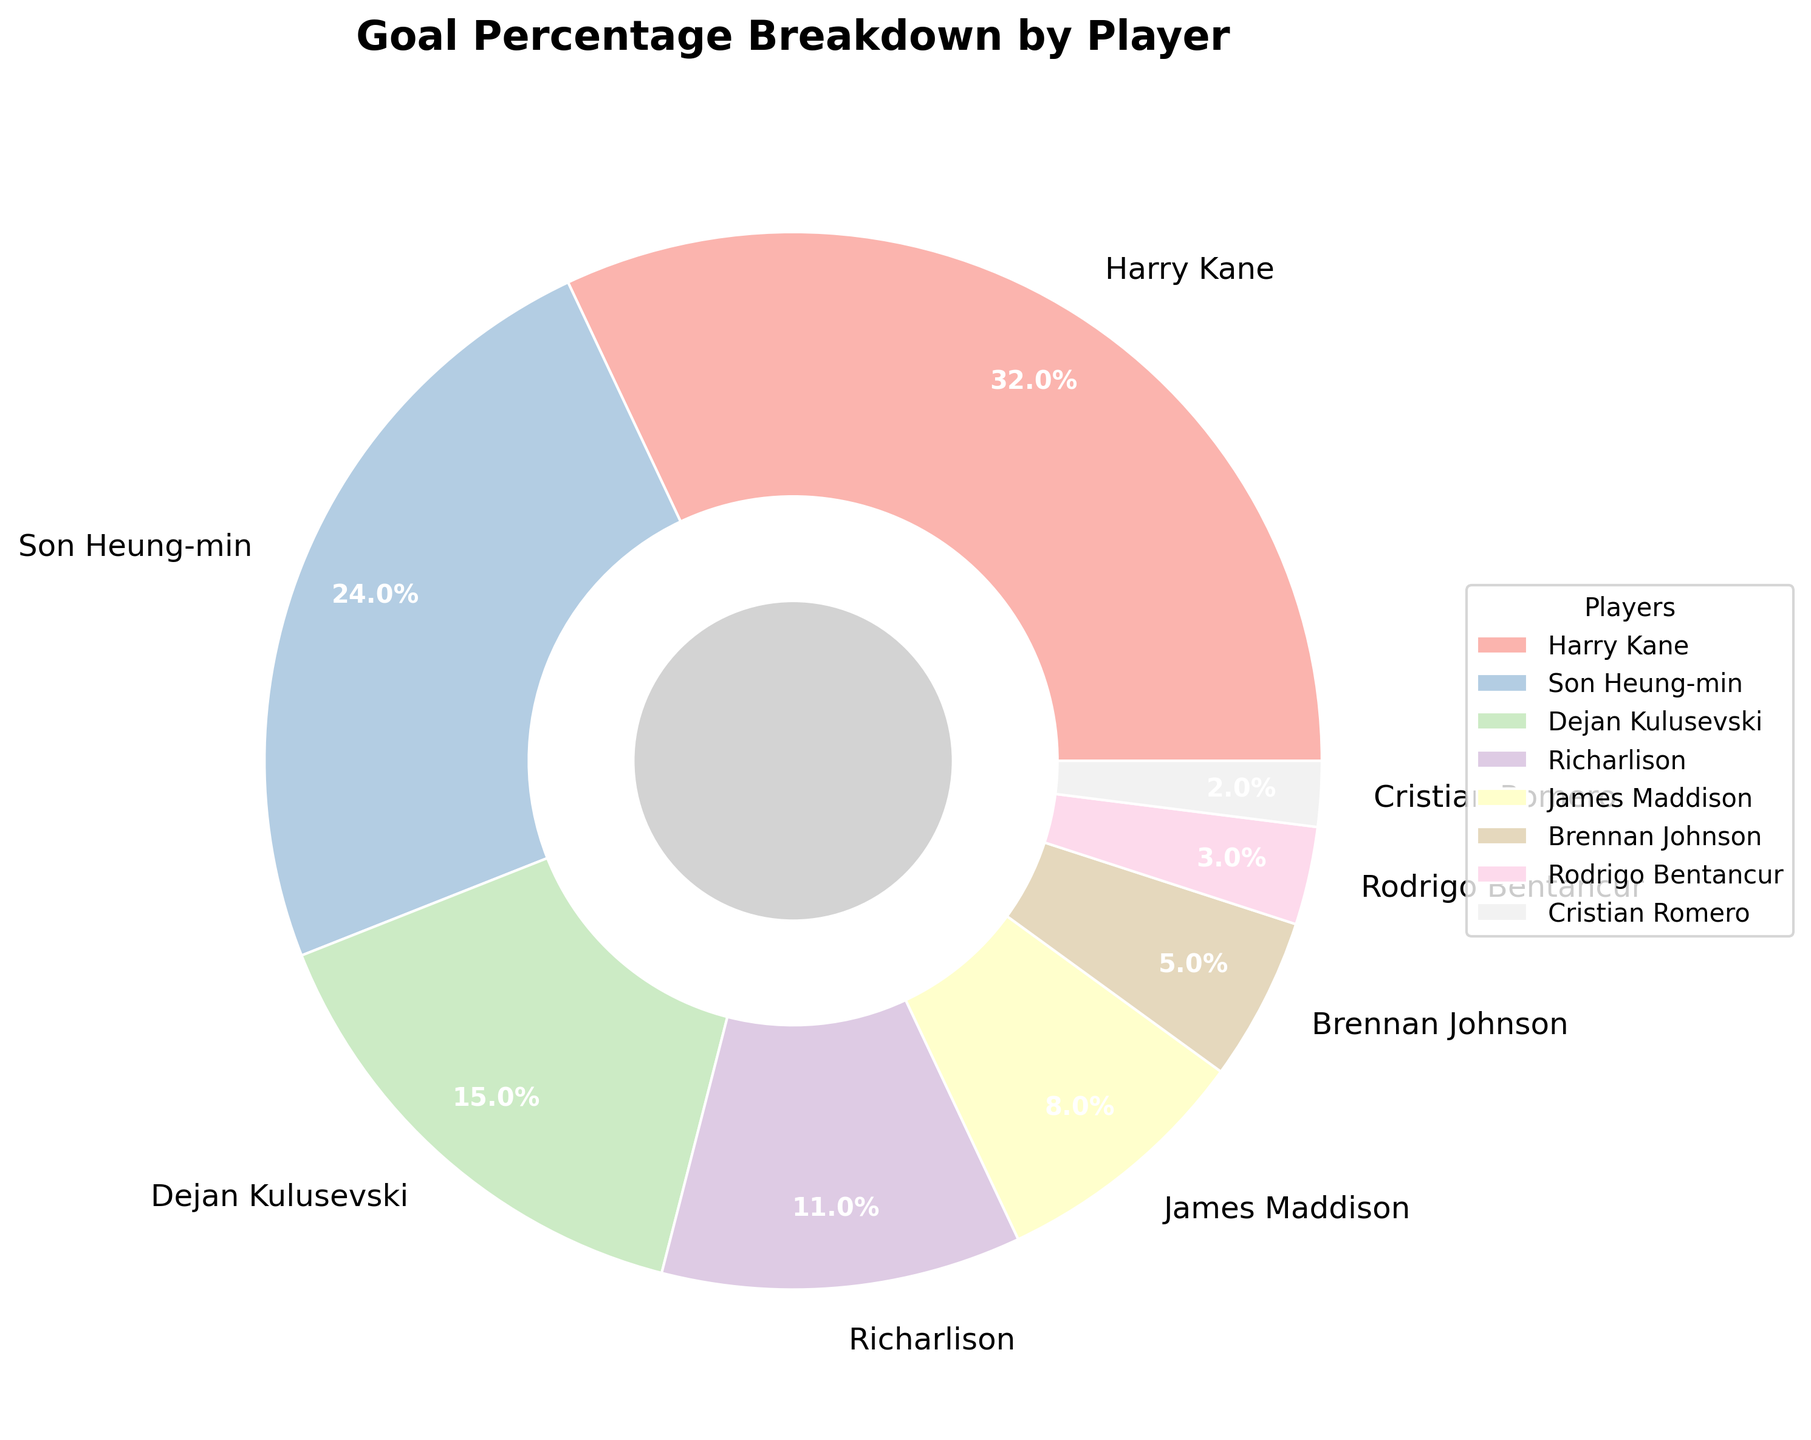What percentage of the team's goals were scored by Harry Kane and Son Heung-min combined? Add the percentages of goals scored by Harry Kane and Son Heung-min: 32% (Harry Kane) + 24% (Son Heung-min)
Answer: 56% Which player scored the least percentage of goals? Identify the player with the smallest segment in the pie chart or the smallest percentage value in the legend, which is 2% for Cristian Romero
Answer: Cristian Romero Who scored more goals, Richarlison or Dejan Kulusevski, and by how much? Compare the percentages of goals scored by Richarlison (11%) and Dejan Kulusevski (15%). Subtract the smaller percentage from the larger percentage: 15% - 11% = 4%
Answer: Dejan Kulusevski, by 4% Which three players together contributed the least percentage of goals? Identify the three smallest slices in the pie chart: Cristian Romero (2%), Rodrigo Bentancur (3%), and Brennan Johnson (5%). Add these percentages: 2% + 3% + 5% = 10%
Answer: Cristian Romero, Rodrigo Bentancur, Brennan Johnson What is the average percentage of goals scored by Son Heung-min, Richarlison, and James Maddison? Calculate the average of the percentages: (24% (Son Heung-min) + 11% (Richarlison) + 8% (James Maddison)) / 3. Total is 24 + 11 + 8 = 43, and dividing 43 by 3 gives approximately 14.33%
Answer: 14.33% Is the combined percentage of goals scored by James Maddison and Brennan Johnson greater than the percentage scored by Dejan Kulusevski? Add the percentages of goals scored by James Maddison (8%) and Brennan Johnson (5%): 8% + 5% = 13%. Compare this to Dejan Kulusevski's 15%: 13% < 15%
Answer: No How does the percentage of goals scored by Harry Kane compare to the sum of goals scored by the bottom three contributors? Sum the percentages of the bottom three contributors: Cristian Romero (2%), Rodrigo Bentancur (3%), Brennan Johnson (5%). 2% + 3% + 5% = 10%. Compare with Harry Kane's 32%: 32% > 10%
Answer: Harry Kane's is greater What is the difference between the highest and lowest percentage of goals scored by any player? Subtract the smallest percentage (2% by Cristian Romero) from the highest percentage (32% by Harry Kane): 32% - 2% = 30%
Answer: 30% 